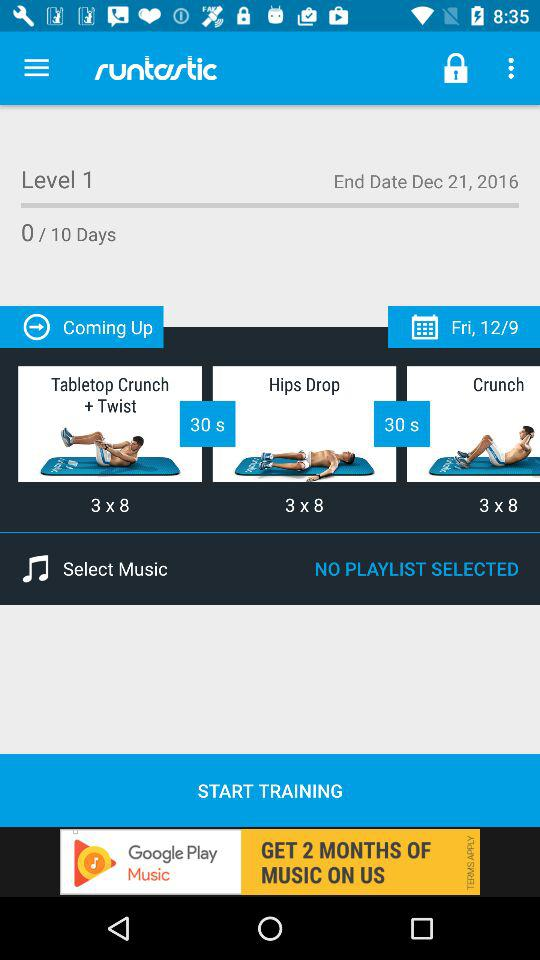Which exercises are in the training? The exercises in the training are "Tabletop Crunch + Twist", "Hips Drop" and "Crunch". 